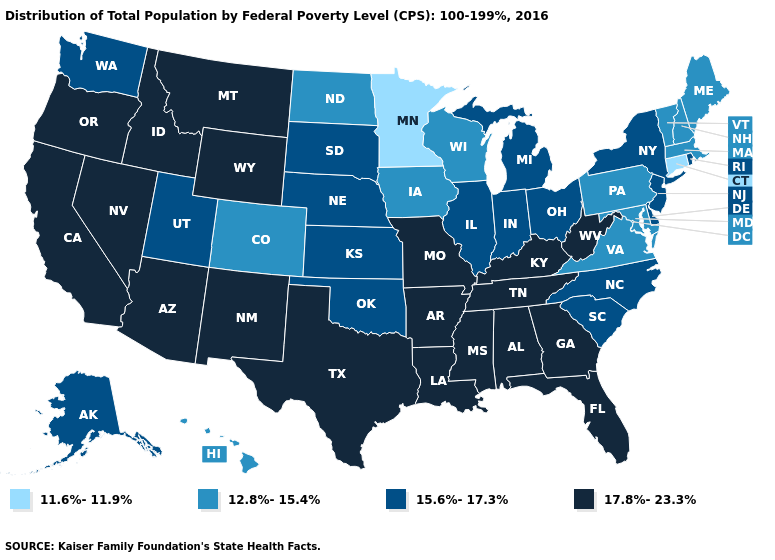Name the states that have a value in the range 12.8%-15.4%?
Give a very brief answer. Colorado, Hawaii, Iowa, Maine, Maryland, Massachusetts, New Hampshire, North Dakota, Pennsylvania, Vermont, Virginia, Wisconsin. Is the legend a continuous bar?
Keep it brief. No. What is the value of Alaska?
Concise answer only. 15.6%-17.3%. Name the states that have a value in the range 12.8%-15.4%?
Quick response, please. Colorado, Hawaii, Iowa, Maine, Maryland, Massachusetts, New Hampshire, North Dakota, Pennsylvania, Vermont, Virginia, Wisconsin. What is the value of Iowa?
Quick response, please. 12.8%-15.4%. Name the states that have a value in the range 15.6%-17.3%?
Quick response, please. Alaska, Delaware, Illinois, Indiana, Kansas, Michigan, Nebraska, New Jersey, New York, North Carolina, Ohio, Oklahoma, Rhode Island, South Carolina, South Dakota, Utah, Washington. Does the map have missing data?
Answer briefly. No. What is the highest value in the MidWest ?
Give a very brief answer. 17.8%-23.3%. What is the value of Connecticut?
Keep it brief. 11.6%-11.9%. Name the states that have a value in the range 11.6%-11.9%?
Concise answer only. Connecticut, Minnesota. Among the states that border Florida , which have the highest value?
Quick response, please. Alabama, Georgia. Name the states that have a value in the range 11.6%-11.9%?
Give a very brief answer. Connecticut, Minnesota. What is the lowest value in the West?
Short answer required. 12.8%-15.4%. Name the states that have a value in the range 11.6%-11.9%?
Quick response, please. Connecticut, Minnesota. Name the states that have a value in the range 15.6%-17.3%?
Answer briefly. Alaska, Delaware, Illinois, Indiana, Kansas, Michigan, Nebraska, New Jersey, New York, North Carolina, Ohio, Oklahoma, Rhode Island, South Carolina, South Dakota, Utah, Washington. 